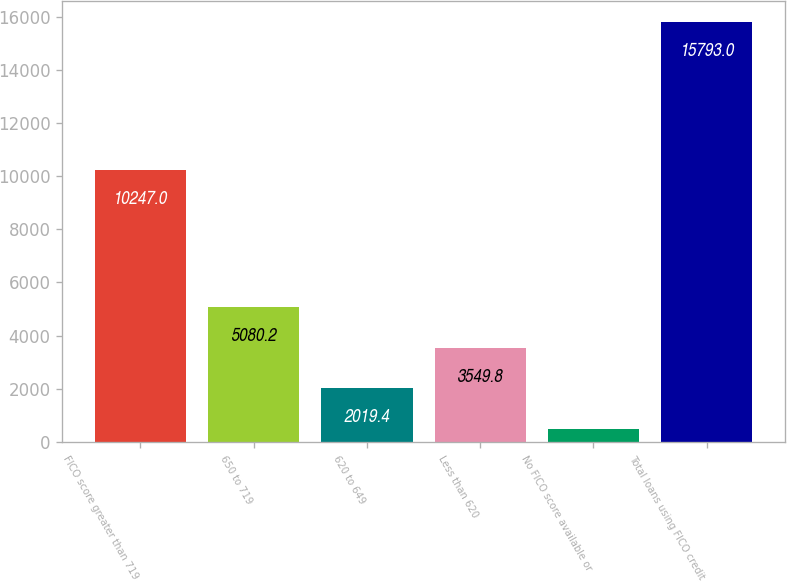Convert chart to OTSL. <chart><loc_0><loc_0><loc_500><loc_500><bar_chart><fcel>FICO score greater than 719<fcel>650 to 719<fcel>620 to 649<fcel>Less than 620<fcel>No FICO score available or<fcel>Total loans using FICO credit<nl><fcel>10247<fcel>5080.2<fcel>2019.4<fcel>3549.8<fcel>489<fcel>15793<nl></chart> 